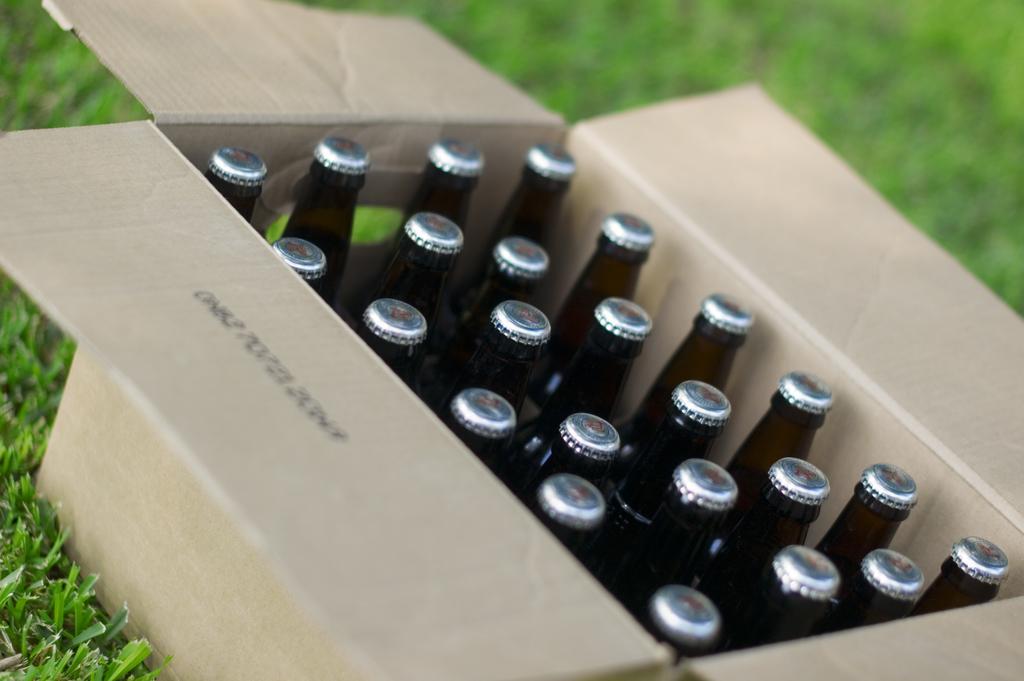Can you describe this image briefly? In this image I see number of bottles in a box and it is on the grass. 